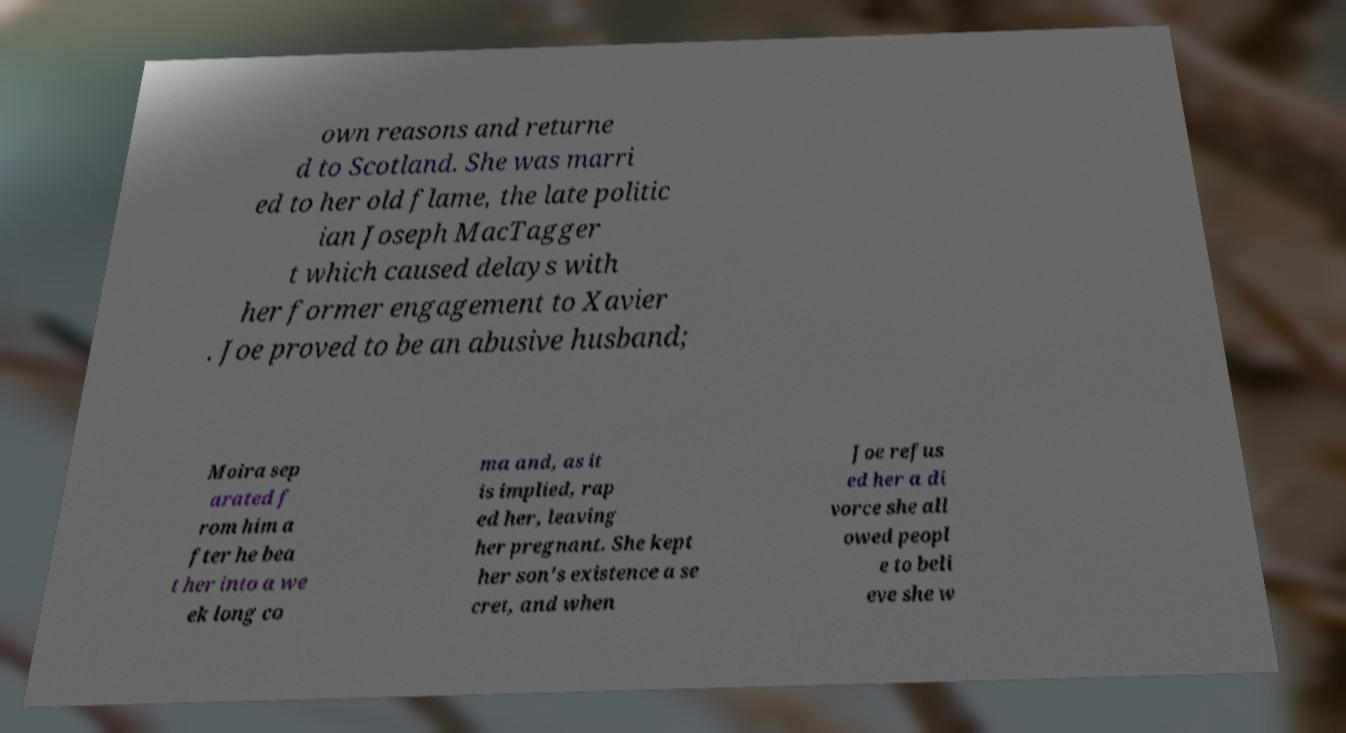For documentation purposes, I need the text within this image transcribed. Could you provide that? own reasons and returne d to Scotland. She was marri ed to her old flame, the late politic ian Joseph MacTagger t which caused delays with her former engagement to Xavier . Joe proved to be an abusive husband; Moira sep arated f rom him a fter he bea t her into a we ek long co ma and, as it is implied, rap ed her, leaving her pregnant. She kept her son's existence a se cret, and when Joe refus ed her a di vorce she all owed peopl e to beli eve she w 